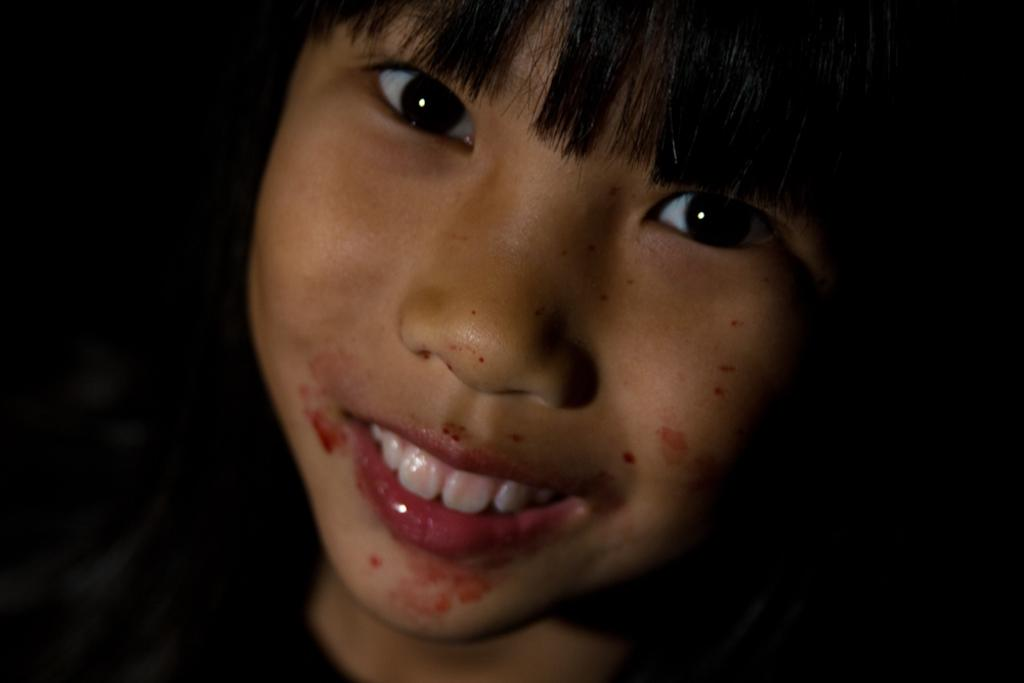Who is the main subject in the image? There is a girl in the image. What is the girl doing in the image? The girl is smiling. What can be observed about the background of the image? The background of the image is dark. What type of government is depicted in the image? There is no depiction of a government in the image; it features a girl smiling against a dark background. 